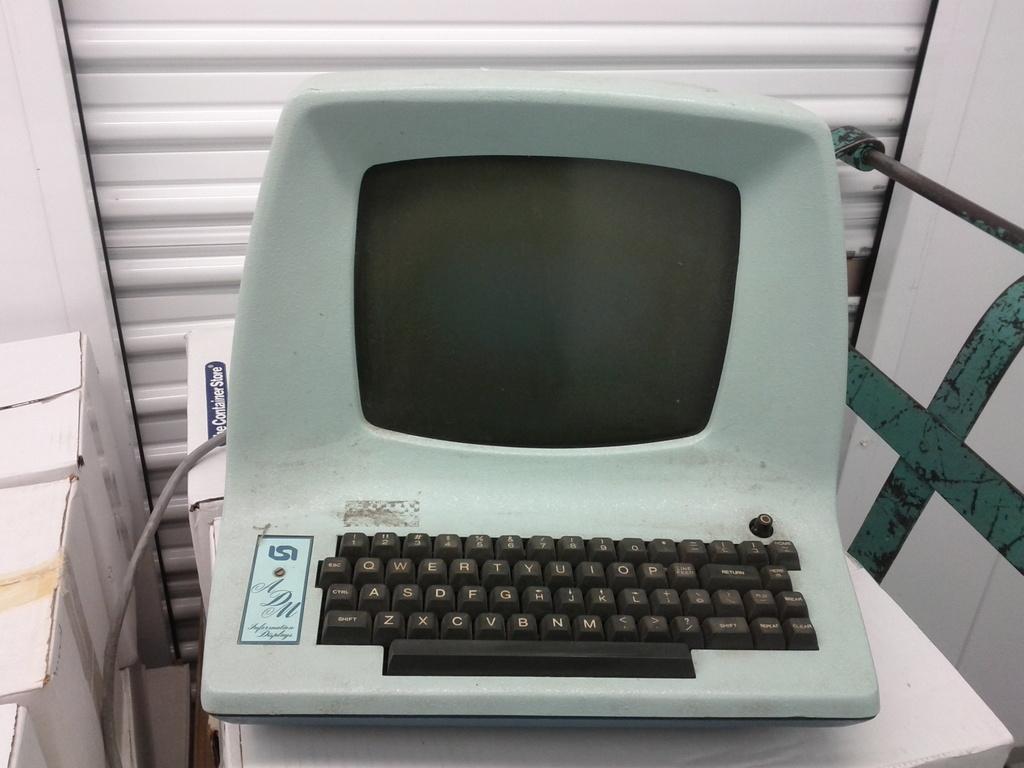What is the letter of the first button in the bottom row?
Offer a very short reply. Z. What is written in white on blue on the box behind the computer?
Offer a very short reply. The container store. 